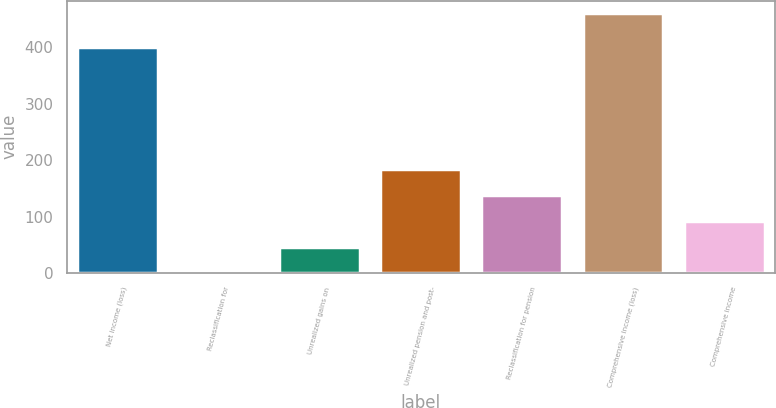Convert chart. <chart><loc_0><loc_0><loc_500><loc_500><bar_chart><fcel>Net income (loss)<fcel>Reclassification for<fcel>Unrealized gains on<fcel>Unrealized pension and post-<fcel>Reclassification for pension<fcel>Comprehensive income (loss)<fcel>Comprehensive income<nl><fcel>400.2<fcel>0.1<fcel>46.25<fcel>184.7<fcel>138.55<fcel>460<fcel>92.4<nl></chart> 